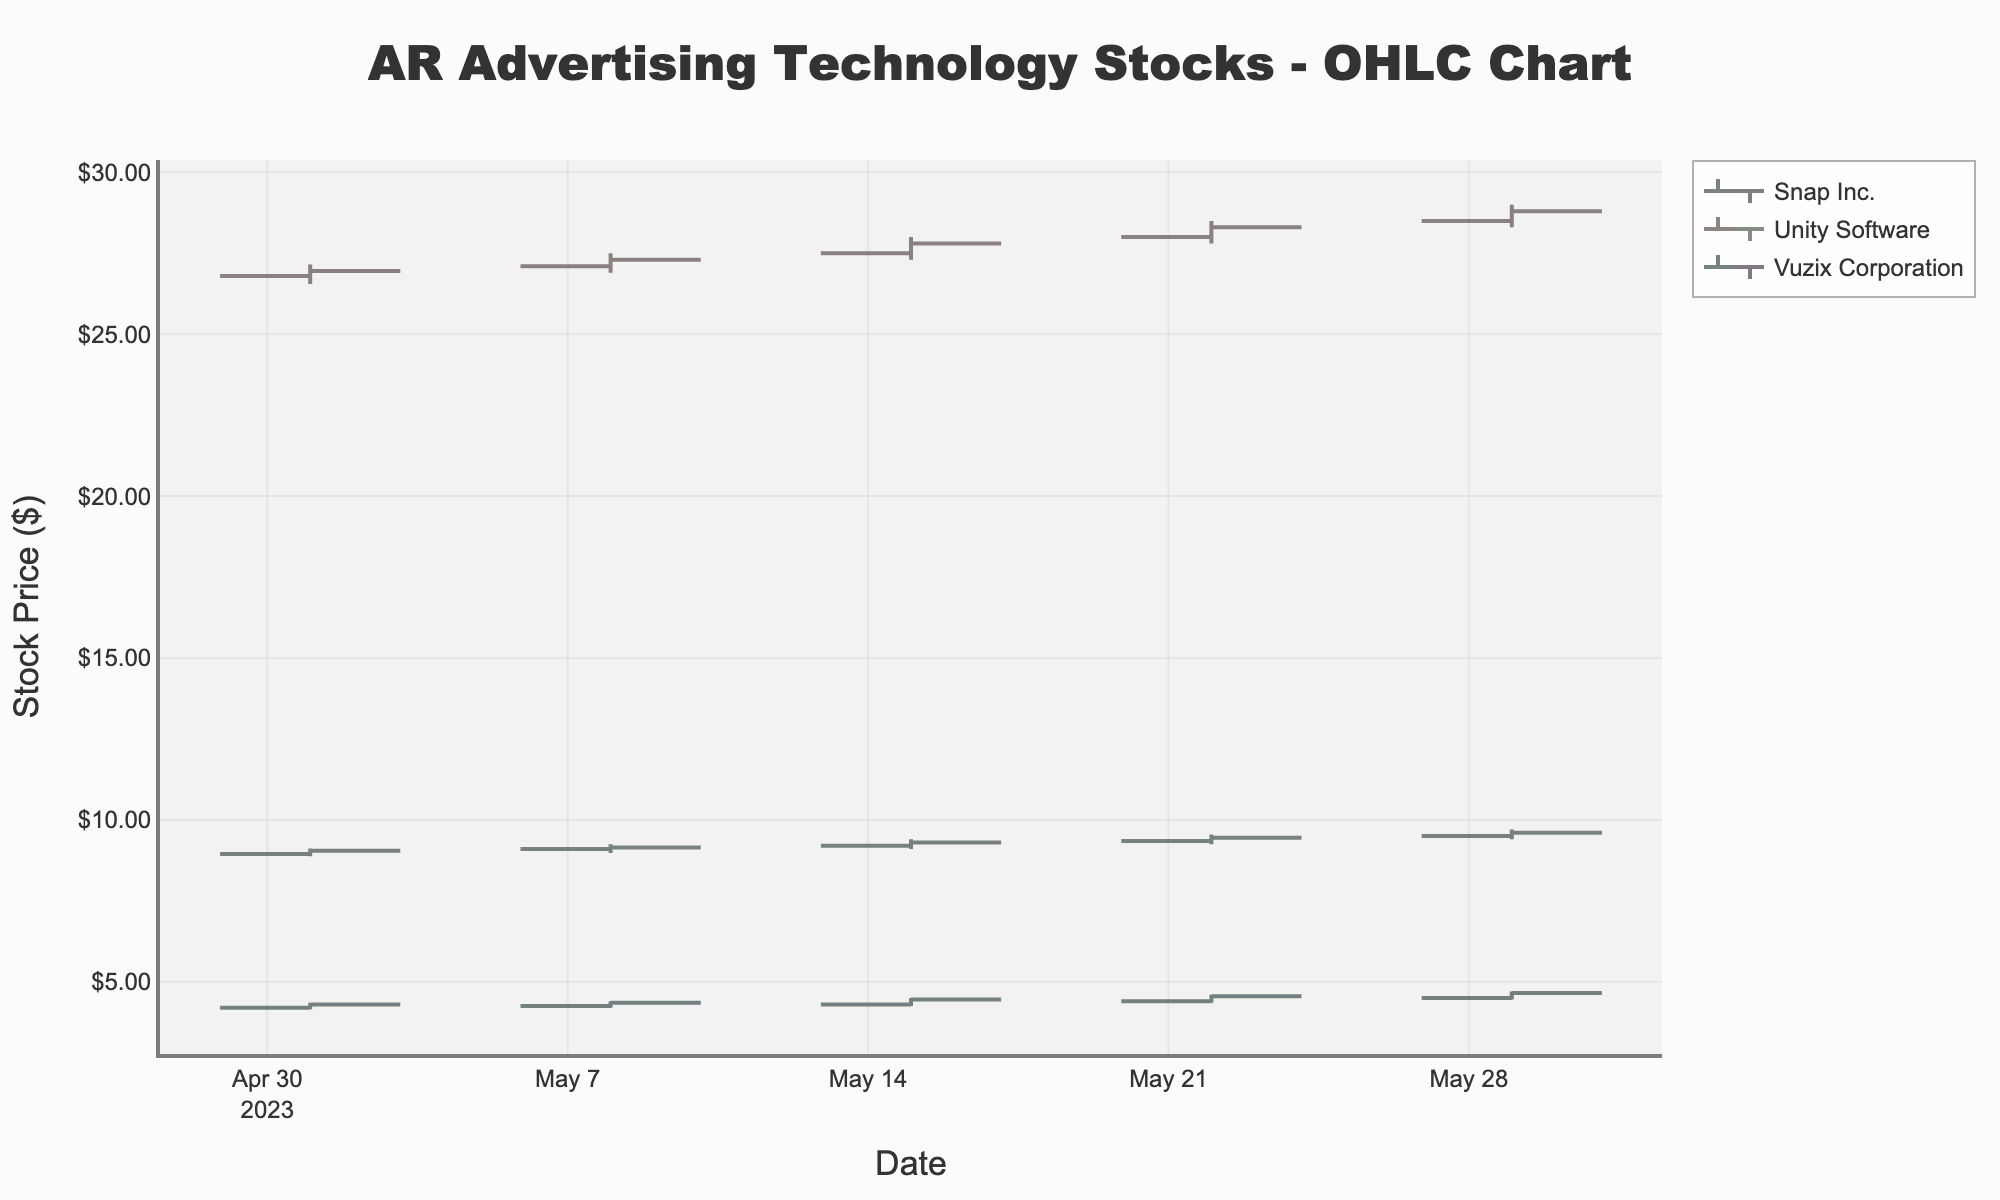What's the title of the figure? The title of the figure is typically located at the top of the chart and is prominently displayed to indicate what the chart represents.
Answer: AR Advertising Technology Stocks - OHLC Chart What is the x-axis title? The x-axis title typically indicates the variable represented along the horizontal axis of the chart.
Answer: Date On which date did Snap Inc. have the highest 'High' value, and what was that value? To find the highest 'High' value for Snap Inc., look along the date axis for Snap Inc. and identify the highest point reached in the 'High' series. Snap Inc. had the highest 'High' value on 2023-05-29 at 9.70.
Answer: 2023-05-29, 9.70 Which company's stock had the highest closing price during the period? To determine the company with the highest closing price, examine the 'Close' prices for all companies and identify the highest value. Unity Software had the highest closing price of 28.80 on 2023-05-29.
Answer: Unity Software What was the difference between the highest and lowest closing prices for Snap Inc. during the month? Calculate the highest and lowest values of the 'Close' prices for Snap Inc., and find the difference between them. The highest closing price was 9.60 and the lowest was 9.05. So, 9.60 - 9.05 = 0.55.
Answer: 0.55 Compare the opening price of Vuzix Corporation on 2023-05-01 to its closing price on the same day. Was it higher, lower, or the same? Compare the 'Open' and 'Close' prices for Vuzix Corporation on 2023-05-01. The opening price was 4.20, and the closing price was 4.30, so the closing price was higher.
Answer: Higher How does the fluctuation in the stock price of Unity Software on 2023-05-15 compare to that of Snap Inc. on the same date? To compare fluctuations, calculate the difference between the 'High' and 'Low' for both companies on 2023-05-15. Unity Software: 28.00 - 27.30 = 0.70. Snap Inc.: 9.40 - 9.10 = 0.30. Unity Software had greater fluctuation (0.70 vs 0.30).
Answer: Unity Software had greater fluctuation What is the overall trend of Snap Inc.'s stock price over the month? To determine the overall trend, observe the closing prices of Snap Inc. over the time period. The closing price increased from 9.05 to 9.60 during the month, indicating a general upward trend.
Answer: Upward trend Between Unity Software and Vuzix Corporation, which company's stock price shows more volatility throughout the month? Volatility can be gauged by examining the range between 'High' and 'Low' prices for each company and comparing the variability. Unity Software's price varied more widely (e.g., 28.50 - 26.55) compared to Vuzix Corporation (e.g., 4.70 - 4.15).
Answer: Unity Software Which company's stocks had increasing closing prices every week? To determine if a company's closing prices increased every week, observe the 'Close' prices sequentially for each company. Snap Inc.'s closing prices increased every week (9.05, 9.15, 9.30, 9.45, 9.60).
Answer: Snap Inc 